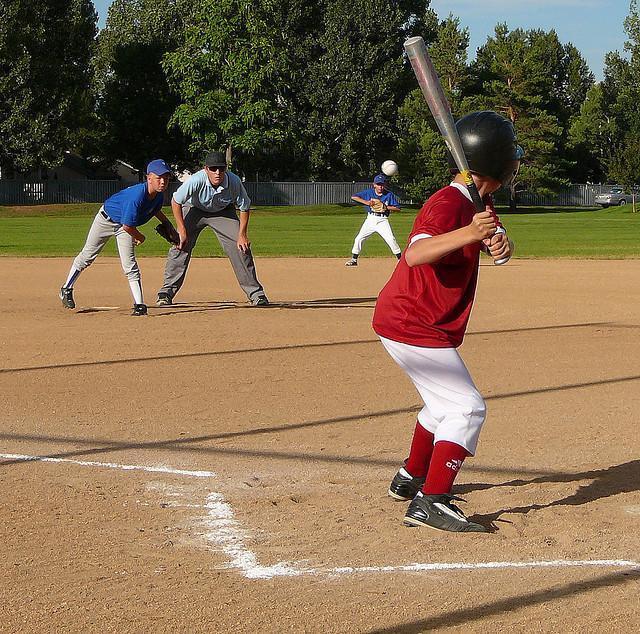How many people are there?
Give a very brief answer. 4. How many blue lanterns are hanging on the left side of the banana bunches?
Give a very brief answer. 0. 